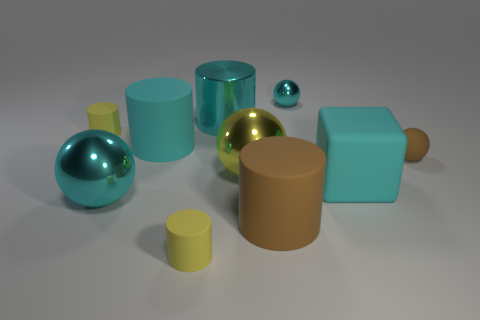There is a matte thing that is in front of the big brown matte cylinder to the right of the large metal sphere that is in front of the big cyan cube; what is its color?
Ensure brevity in your answer.  Yellow. What is the color of the other rubber cylinder that is the same size as the brown cylinder?
Your answer should be very brief. Cyan. What number of rubber things are either tiny cylinders or yellow things?
Keep it short and to the point. 2. There is a tiny ball that is the same material as the large block; what is its color?
Your answer should be very brief. Brown. The tiny yellow cylinder behind the big brown rubber cylinder in front of the shiny cylinder is made of what material?
Provide a short and direct response. Rubber. What number of objects are spheres that are in front of the small brown object or yellow rubber cylinders behind the big brown thing?
Provide a short and direct response. 3. What is the size of the cyan cylinder behind the small yellow matte object behind the large cyan rubber thing left of the tiny cyan metal thing?
Ensure brevity in your answer.  Large. Are there the same number of cyan cubes that are in front of the large cube and small green objects?
Keep it short and to the point. Yes. Are there any other things that are the same shape as the big yellow metal thing?
Keep it short and to the point. Yes. Do the tiny cyan metal thing and the tiny rubber thing on the right side of the small cyan ball have the same shape?
Offer a very short reply. Yes. 